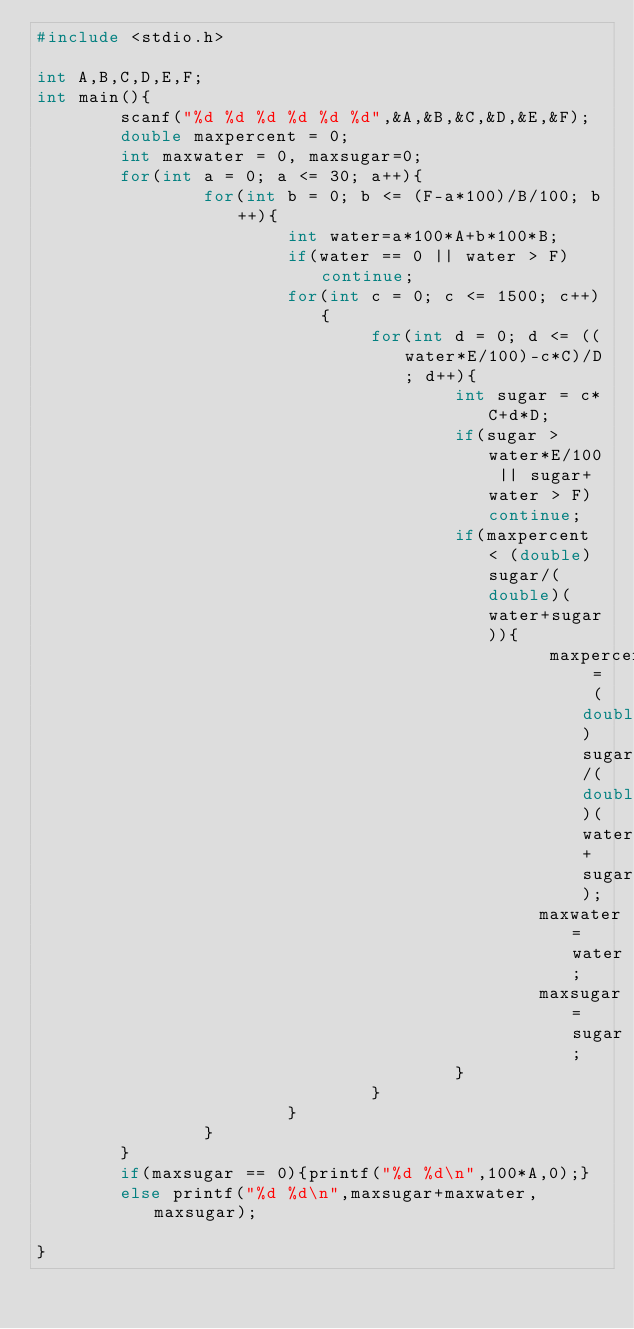Convert code to text. <code><loc_0><loc_0><loc_500><loc_500><_C++_>#include <stdio.h>

int A,B,C,D,E,F;
int main(){
        scanf("%d %d %d %d %d %d",&A,&B,&C,&D,&E,&F);
        double maxpercent = 0;
        int maxwater = 0, maxsugar=0;
        for(int a = 0; a <= 30; a++){
                for(int b = 0; b <= (F-a*100)/B/100; b++){
                        int water=a*100*A+b*100*B;
                        if(water == 0 || water > F) continue;
                        for(int c = 0; c <= 1500; c++){
                                for(int d = 0; d <= ((water*E/100)-c*C)/D; d++){
                                        int sugar = c*C+d*D;
                                        if(sugar > water*E/100 || sugar+water > F) continue;
                                        if(maxpercent < (double)sugar/(double)(water+sugar)){
                                                 maxpercent = (double)sugar/(double)(water+sugar);
                                                maxwater=water;
                                                maxsugar=sugar;
                                        }
                                }
                        }
                }
        }
        if(maxsugar == 0){printf("%d %d\n",100*A,0);}
        else printf("%d %d\n",maxsugar+maxwater,maxsugar);

}</code> 